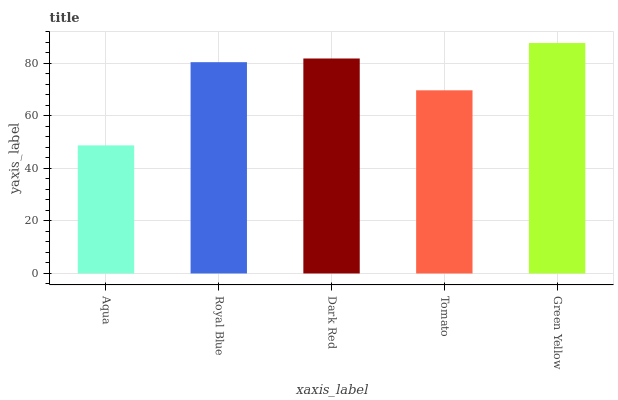Is Aqua the minimum?
Answer yes or no. Yes. Is Green Yellow the maximum?
Answer yes or no. Yes. Is Royal Blue the minimum?
Answer yes or no. No. Is Royal Blue the maximum?
Answer yes or no. No. Is Royal Blue greater than Aqua?
Answer yes or no. Yes. Is Aqua less than Royal Blue?
Answer yes or no. Yes. Is Aqua greater than Royal Blue?
Answer yes or no. No. Is Royal Blue less than Aqua?
Answer yes or no. No. Is Royal Blue the high median?
Answer yes or no. Yes. Is Royal Blue the low median?
Answer yes or no. Yes. Is Green Yellow the high median?
Answer yes or no. No. Is Green Yellow the low median?
Answer yes or no. No. 